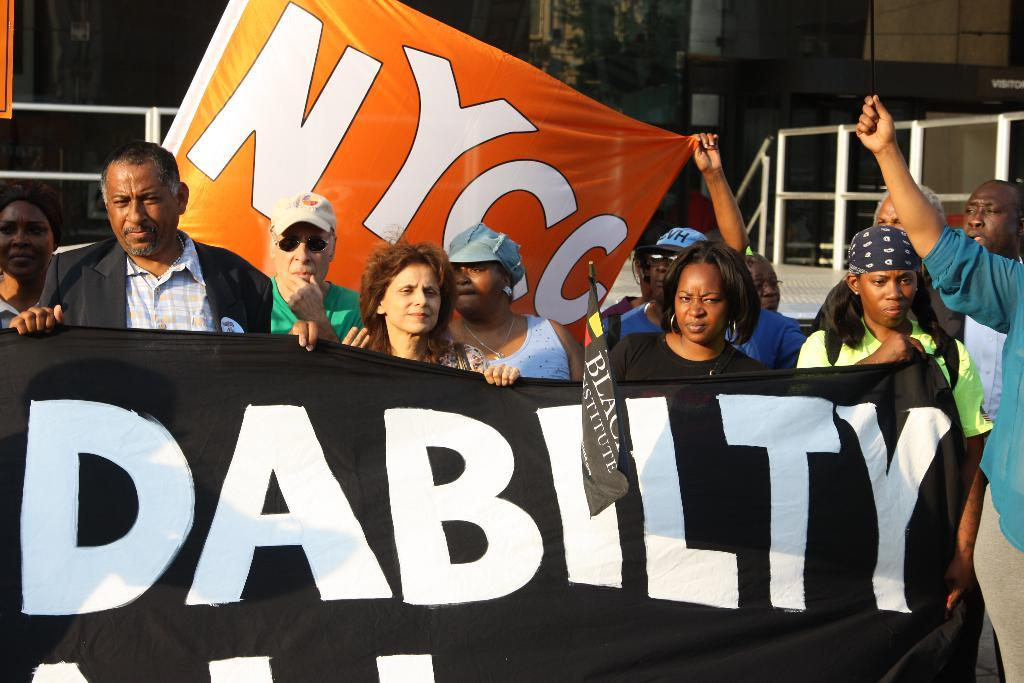What are the persons in the image doing? The persons in the image are standing on the ground and holding flags. What can be seen in the background of the image? There are stairs and a building in the background of the image. What type of cactus can be seen growing on the stairs in the image? There is no cactus present in the image, and the stairs do not have any plants growing on them. 